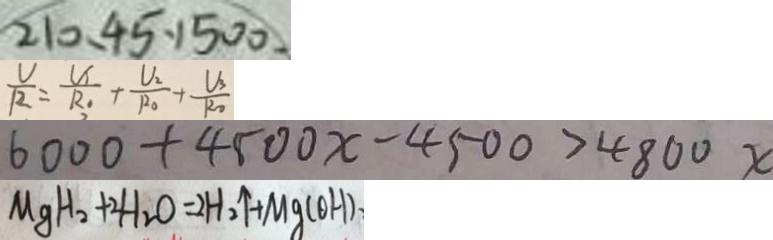Convert formula to latex. <formula><loc_0><loc_0><loc_500><loc_500>2 1 0 、 4 5 、 1 5 0 0 . 
 \frac { U } { R } = \frac { U _ { 1 } } { R _ { 1 } } + \frac { U _ { 2 } } { R _ { 0 } } + \frac { V _ { 3 } } { R _ { 0 } } 
 6 0 0 0 + 4 5 0 0 x - 4 5 0 0 > 4 8 0 0 x 
 M g H _ { 2 } + 2 H _ { 2 } O = 2 H _ { 2 } \uparrow + M g ( O H )</formula> 